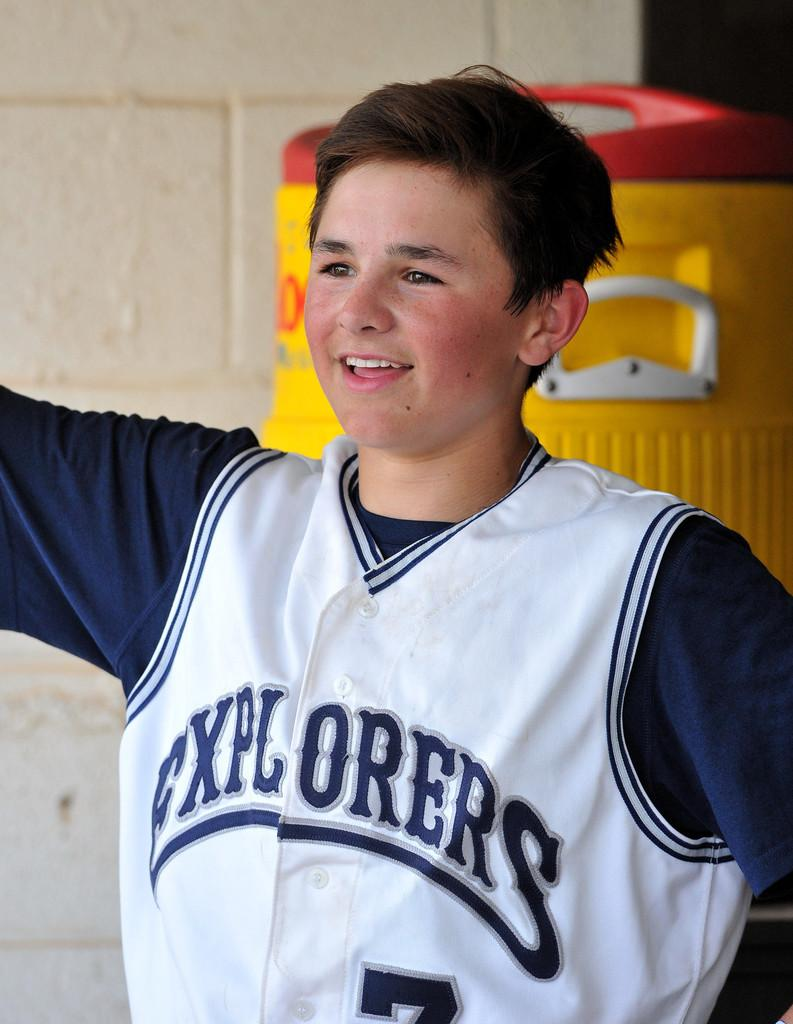<image>
Give a short and clear explanation of the subsequent image. A boy is in a jersey with Explorers on the front. 